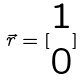<formula> <loc_0><loc_0><loc_500><loc_500>\vec { r } = [ \begin{matrix} 1 \\ 0 \end{matrix} ]</formula> 